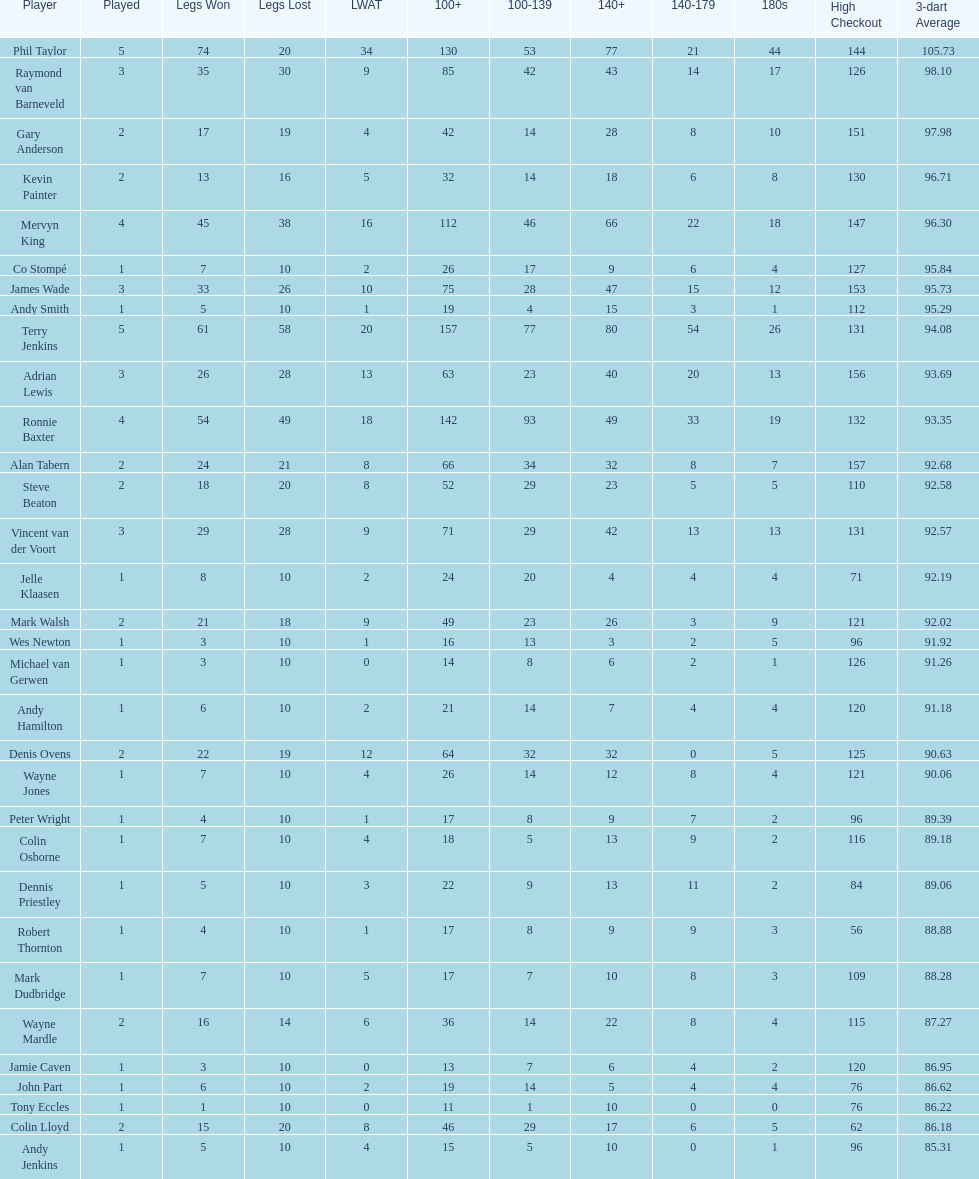Mark walsh's average is above/below 93? Below. Would you mind parsing the complete table? {'header': ['Player', 'Played', 'Legs Won', 'Legs Lost', 'LWAT', '100+', '100-139', '140+', '140-179', '180s', 'High Checkout', '3-dart Average'], 'rows': [['Phil Taylor', '5', '74', '20', '34', '130', '53', '77', '21', '44', '144', '105.73'], ['Raymond van Barneveld', '3', '35', '30', '9', '85', '42', '43', '14', '17', '126', '98.10'], ['Gary Anderson', '2', '17', '19', '4', '42', '14', '28', '8', '10', '151', '97.98'], ['Kevin Painter', '2', '13', '16', '5', '32', '14', '18', '6', '8', '130', '96.71'], ['Mervyn King', '4', '45', '38', '16', '112', '46', '66', '22', '18', '147', '96.30'], ['Co Stompé', '1', '7', '10', '2', '26', '17', '9', '6', '4', '127', '95.84'], ['James Wade', '3', '33', '26', '10', '75', '28', '47', '15', '12', '153', '95.73'], ['Andy Smith', '1', '5', '10', '1', '19', '4', '15', '3', '1', '112', '95.29'], ['Terry Jenkins', '5', '61', '58', '20', '157', '77', '80', '54', '26', '131', '94.08'], ['Adrian Lewis', '3', '26', '28', '13', '63', '23', '40', '20', '13', '156', '93.69'], ['Ronnie Baxter', '4', '54', '49', '18', '142', '93', '49', '33', '19', '132', '93.35'], ['Alan Tabern', '2', '24', '21', '8', '66', '34', '32', '8', '7', '157', '92.68'], ['Steve Beaton', '2', '18', '20', '8', '52', '29', '23', '5', '5', '110', '92.58'], ['Vincent van der Voort', '3', '29', '28', '9', '71', '29', '42', '13', '13', '131', '92.57'], ['Jelle Klaasen', '1', '8', '10', '2', '24', '20', '4', '4', '4', '71', '92.19'], ['Mark Walsh', '2', '21', '18', '9', '49', '23', '26', '3', '9', '121', '92.02'], ['Wes Newton', '1', '3', '10', '1', '16', '13', '3', '2', '5', '96', '91.92'], ['Michael van Gerwen', '1', '3', '10', '0', '14', '8', '6', '2', '1', '126', '91.26'], ['Andy Hamilton', '1', '6', '10', '2', '21', '14', '7', '4', '4', '120', '91.18'], ['Denis Ovens', '2', '22', '19', '12', '64', '32', '32', '0', '5', '125', '90.63'], ['Wayne Jones', '1', '7', '10', '4', '26', '14', '12', '8', '4', '121', '90.06'], ['Peter Wright', '1', '4', '10', '1', '17', '8', '9', '7', '2', '96', '89.39'], ['Colin Osborne', '1', '7', '10', '4', '18', '5', '13', '9', '2', '116', '89.18'], ['Dennis Priestley', '1', '5', '10', '3', '22', '9', '13', '11', '2', '84', '89.06'], ['Robert Thornton', '1', '4', '10', '1', '17', '8', '9', '9', '3', '56', '88.88'], ['Mark Dudbridge', '1', '7', '10', '5', '17', '7', '10', '8', '3', '109', '88.28'], ['Wayne Mardle', '2', '16', '14', '6', '36', '14', '22', '8', '4', '115', '87.27'], ['Jamie Caven', '1', '3', '10', '0', '13', '7', '6', '4', '2', '120', '86.95'], ['John Part', '1', '6', '10', '2', '19', '14', '5', '4', '4', '76', '86.62'], ['Tony Eccles', '1', '1', '10', '0', '11', '1', '10', '0', '0', '76', '86.22'], ['Colin Lloyd', '2', '15', '20', '8', '46', '29', '17', '6', '5', '62', '86.18'], ['Andy Jenkins', '1', '5', '10', '4', '15', '5', '10', '0', '1', '96', '85.31']]} 